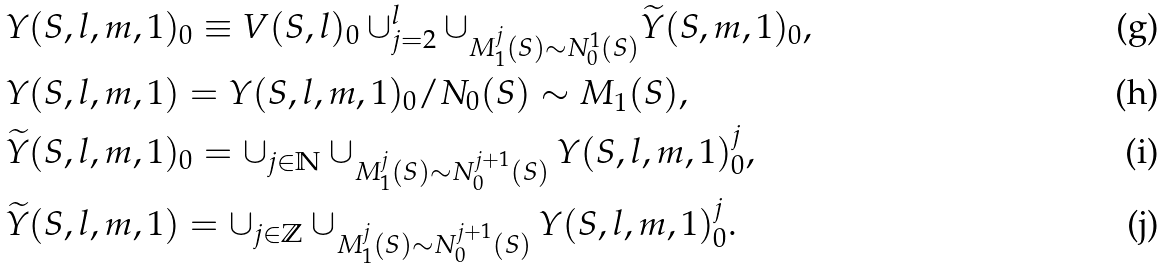Convert formula to latex. <formula><loc_0><loc_0><loc_500><loc_500>& Y ( S , l , m , 1 ) _ { 0 } \equiv V ( S , l ) _ { 0 } \cup _ { j = 2 } ^ { l } \cup _ { M _ { 1 } ^ { j } ( S ) \sim N ^ { 1 } _ { 0 } ( S ) } \widetilde { Y } ( S , m , 1 ) _ { 0 } , \\ & Y ( S , l , m , 1 ) = Y ( S , l , m , 1 ) _ { 0 } / N _ { 0 } ( S ) \sim M _ { 1 } ( S ) , \\ & \widetilde { Y } ( S , l , m , 1 ) _ { 0 } = \cup _ { j \in \mathbb { N } } \cup _ { M _ { 1 } ^ { j } ( S ) \sim N _ { 0 } ^ { j + 1 } ( S ) } Y ( S , l , m , 1 ) _ { 0 } ^ { j } , \\ & \widetilde { Y } ( S , l , m , 1 ) = \cup _ { j \in \mathbb { Z } } \cup _ { M _ { 1 } ^ { j } ( S ) \sim N _ { 0 } ^ { j + 1 } ( S ) } Y ( S , l , m , 1 ) _ { 0 } ^ { j } .</formula> 